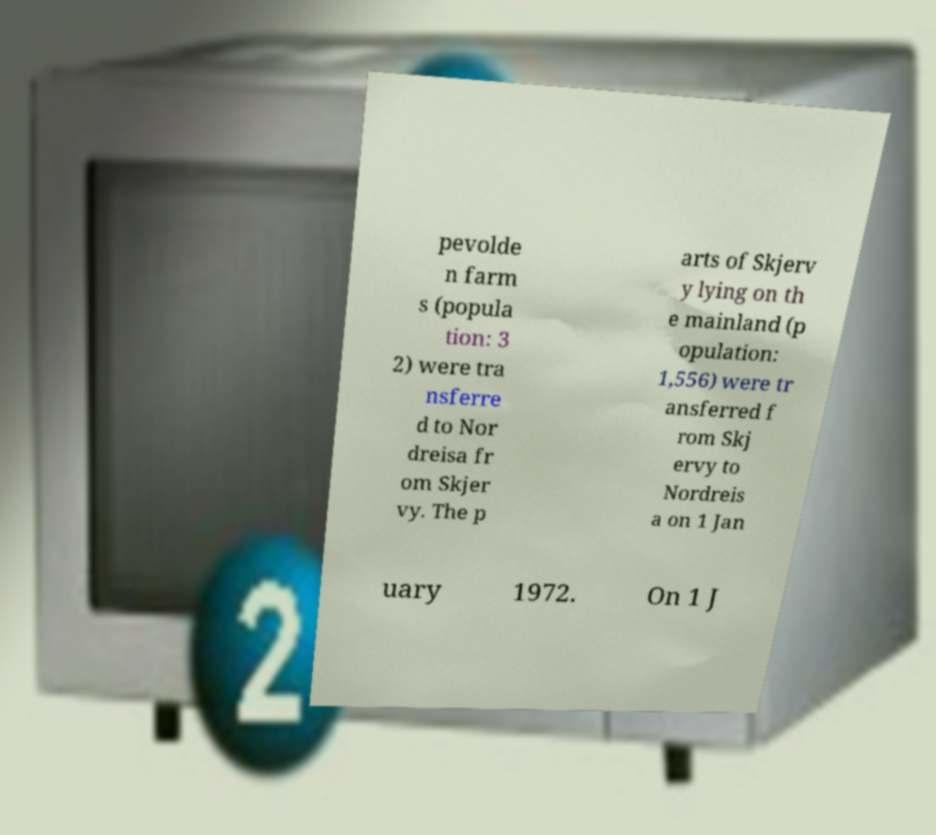There's text embedded in this image that I need extracted. Can you transcribe it verbatim? pevolde n farm s (popula tion: 3 2) were tra nsferre d to Nor dreisa fr om Skjer vy. The p arts of Skjerv y lying on th e mainland (p opulation: 1,556) were tr ansferred f rom Skj ervy to Nordreis a on 1 Jan uary 1972. On 1 J 